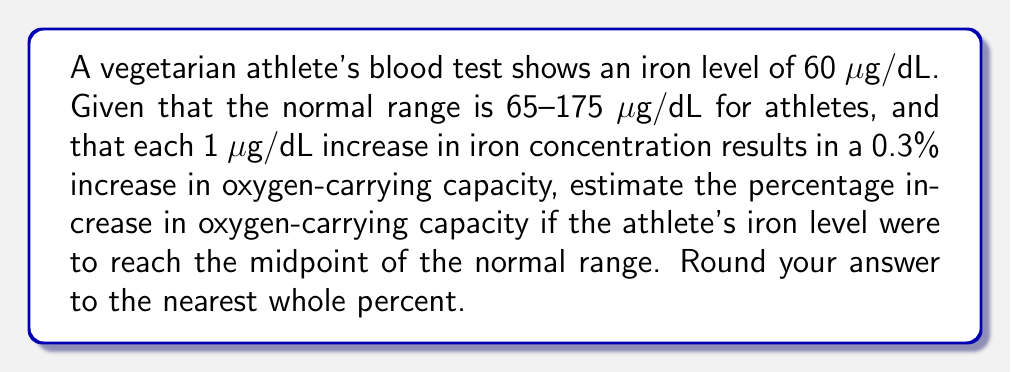Could you help me with this problem? 1. Calculate the midpoint of the normal iron range:
   $\text{Midpoint} = \frac{65 + 175}{2} = 120 \text{ μg/dL}$

2. Calculate the difference between the midpoint and current iron level:
   $\text{Difference} = 120 - 60 = 60 \text{ μg/dL}$

3. Calculate the percentage increase in oxygen-carrying capacity:
   Each 1 μg/dL increase results in a 0.3% increase in capacity.
   $\text{Increase} = 60 \text{ μg/dL} \times 0.3\% \text{/μg/dL} = 18\%$

4. Round to the nearest whole percent:
   18% rounds to 18%
Answer: 18% 